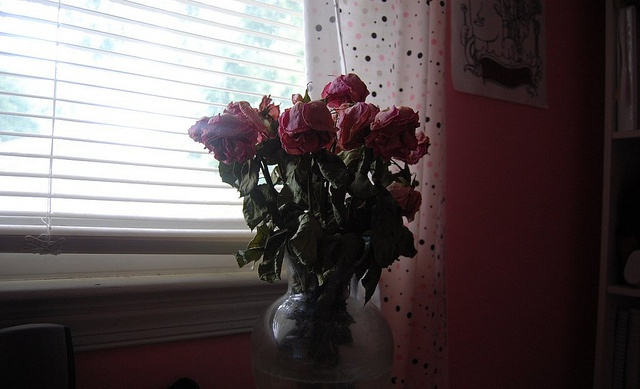Describe the objects in this image and their specific colors. I can see potted plant in white, black, gray, and maroon tones and vase in white, black, gray, and darkgray tones in this image. 